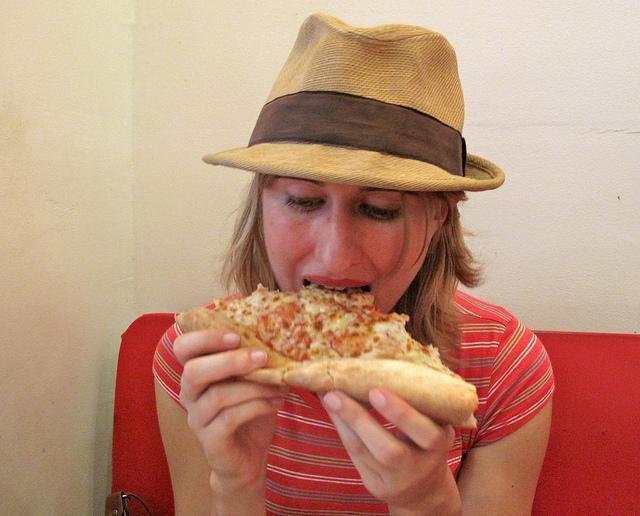How many blue cars are in the picture?
Give a very brief answer. 0. 